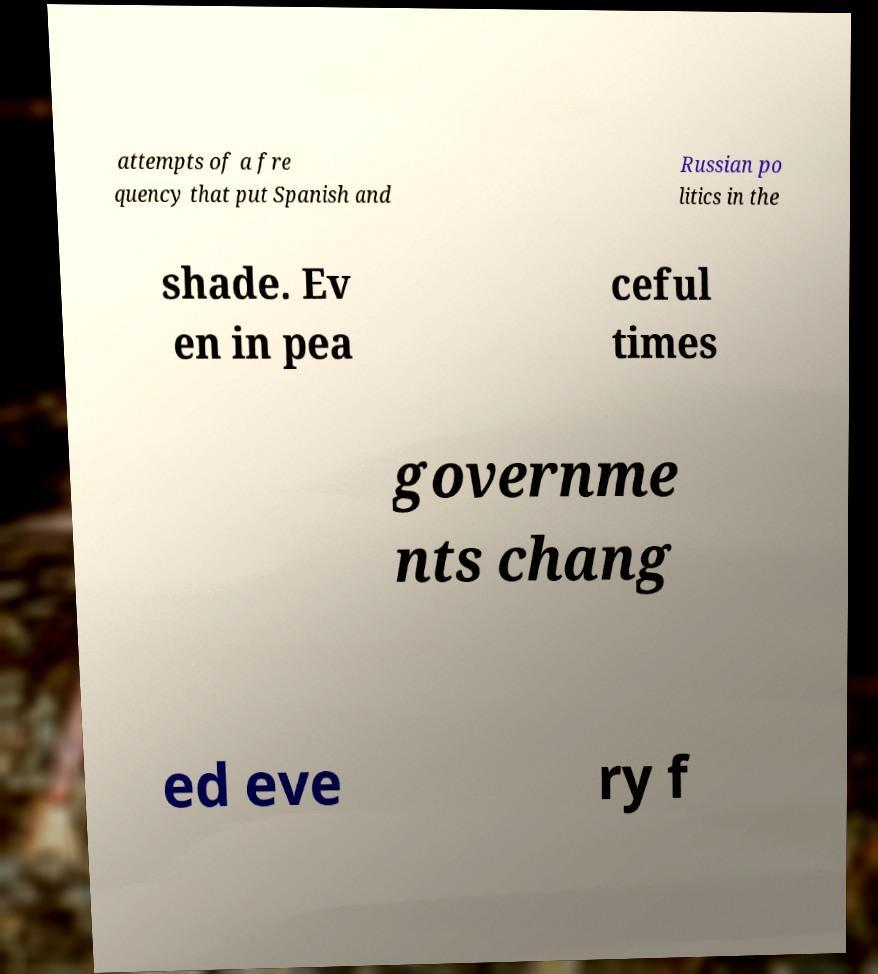Can you accurately transcribe the text from the provided image for me? attempts of a fre quency that put Spanish and Russian po litics in the shade. Ev en in pea ceful times governme nts chang ed eve ry f 